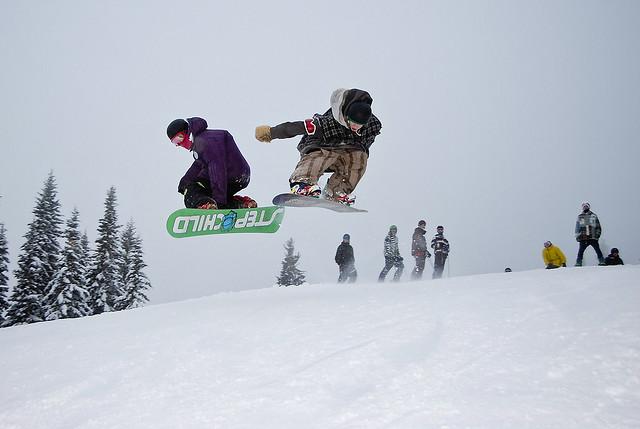What is written on the green board?
Concise answer only. Stepchild. What are the people wearing on their feet?
Give a very brief answer. Snowboards. Is there a summer sport, not unlike this one?
Short answer required. Yes. Are they surfing or snowboarding?
Be succinct. Snowboarding. 